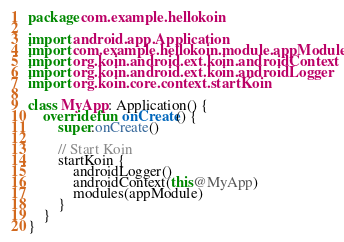<code> <loc_0><loc_0><loc_500><loc_500><_Kotlin_>package com.example.hellokoin

import android.app.Application
import com.example.hellokoin.module.appModule
import org.koin.android.ext.koin.androidContext
import org.koin.android.ext.koin.androidLogger
import org.koin.core.context.startKoin

class MyApp: Application() {
    override fun onCreate() {
        super.onCreate()

        // Start Koin
        startKoin {
            androidLogger()
            androidContext(this@MyApp)
            modules(appModule)
        }
    }
}</code> 